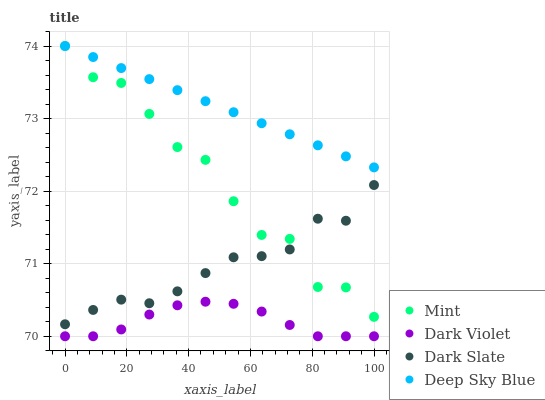Does Dark Violet have the minimum area under the curve?
Answer yes or no. Yes. Does Deep Sky Blue have the maximum area under the curve?
Answer yes or no. Yes. Does Mint have the minimum area under the curve?
Answer yes or no. No. Does Mint have the maximum area under the curve?
Answer yes or no. No. Is Deep Sky Blue the smoothest?
Answer yes or no. Yes. Is Mint the roughest?
Answer yes or no. Yes. Is Mint the smoothest?
Answer yes or no. No. Is Deep Sky Blue the roughest?
Answer yes or no. No. Does Dark Violet have the lowest value?
Answer yes or no. Yes. Does Mint have the lowest value?
Answer yes or no. No. Does Deep Sky Blue have the highest value?
Answer yes or no. Yes. Does Dark Violet have the highest value?
Answer yes or no. No. Is Dark Slate less than Deep Sky Blue?
Answer yes or no. Yes. Is Deep Sky Blue greater than Dark Violet?
Answer yes or no. Yes. Does Deep Sky Blue intersect Mint?
Answer yes or no. Yes. Is Deep Sky Blue less than Mint?
Answer yes or no. No. Is Deep Sky Blue greater than Mint?
Answer yes or no. No. Does Dark Slate intersect Deep Sky Blue?
Answer yes or no. No. 